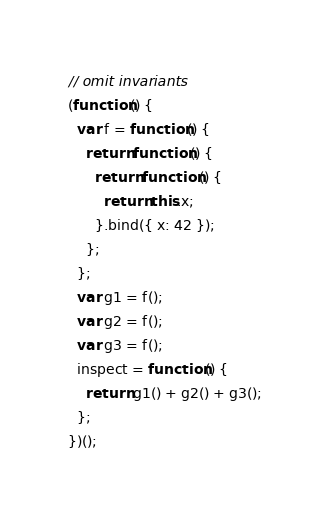Convert code to text. <code><loc_0><loc_0><loc_500><loc_500><_JavaScript_>// omit invariants
(function() {
  var f = function() {
    return function() {
      return function() {
        return this.x;
      }.bind({ x: 42 });
    };
  };
  var g1 = f();
  var g2 = f();
  var g3 = f();
  inspect = function() {
    return g1() + g2() + g3();
  };
})();
</code> 